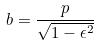<formula> <loc_0><loc_0><loc_500><loc_500>b = \frac { p } { \sqrt { 1 - \epsilon ^ { 2 } } }</formula> 